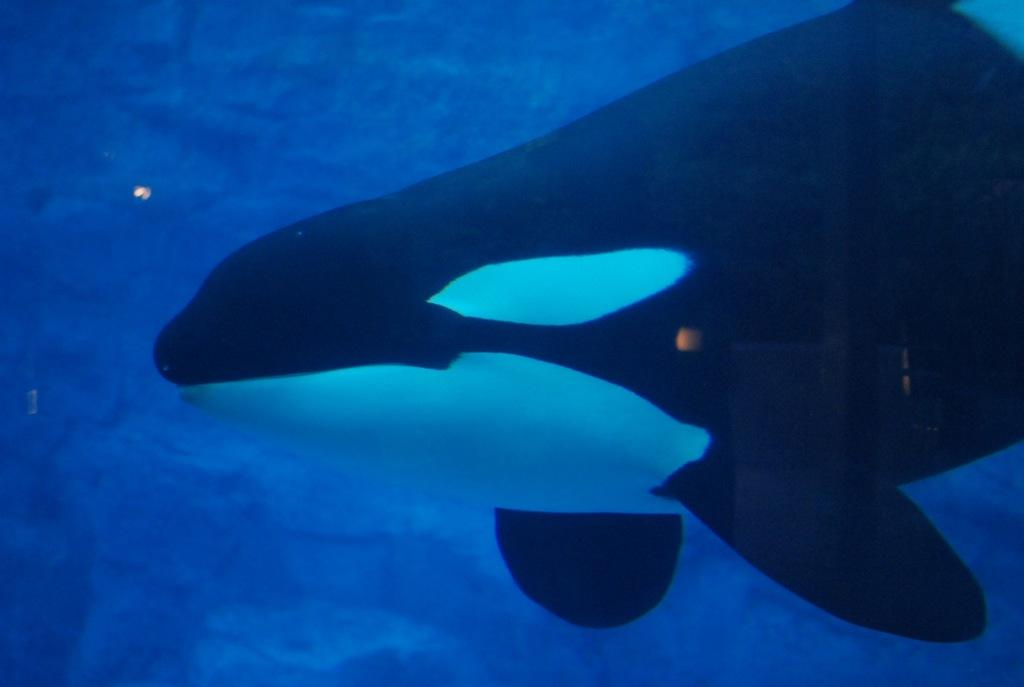What type of animal is in the image? The type of animal cannot be determined from the provided facts. Where is the animal located in the image? The animal is in the water. What color is the pen used to write on the snow in the image? There is no pen or snow present in the image; it features an animal in the water. 